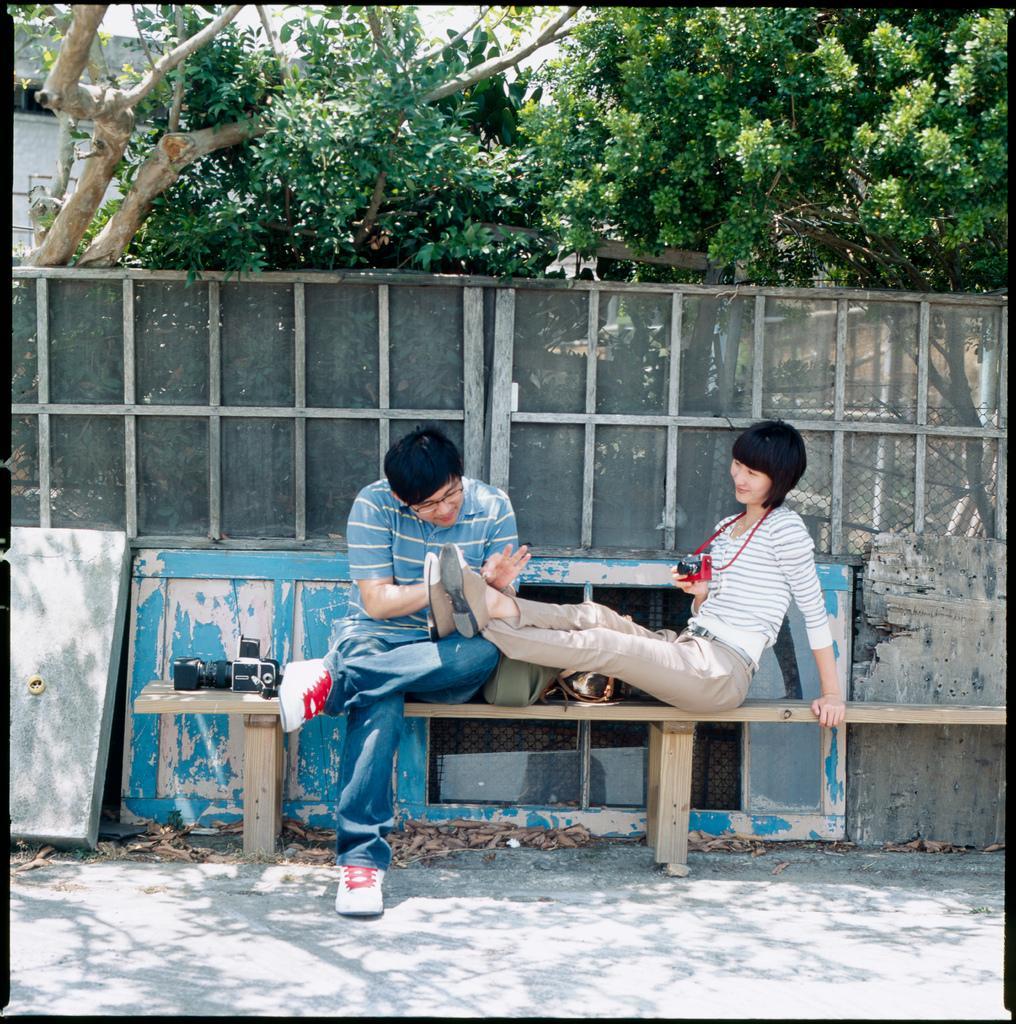Please provide a concise description of this image. As we can see in the image there are trees, bench and two people sitting on bench. 